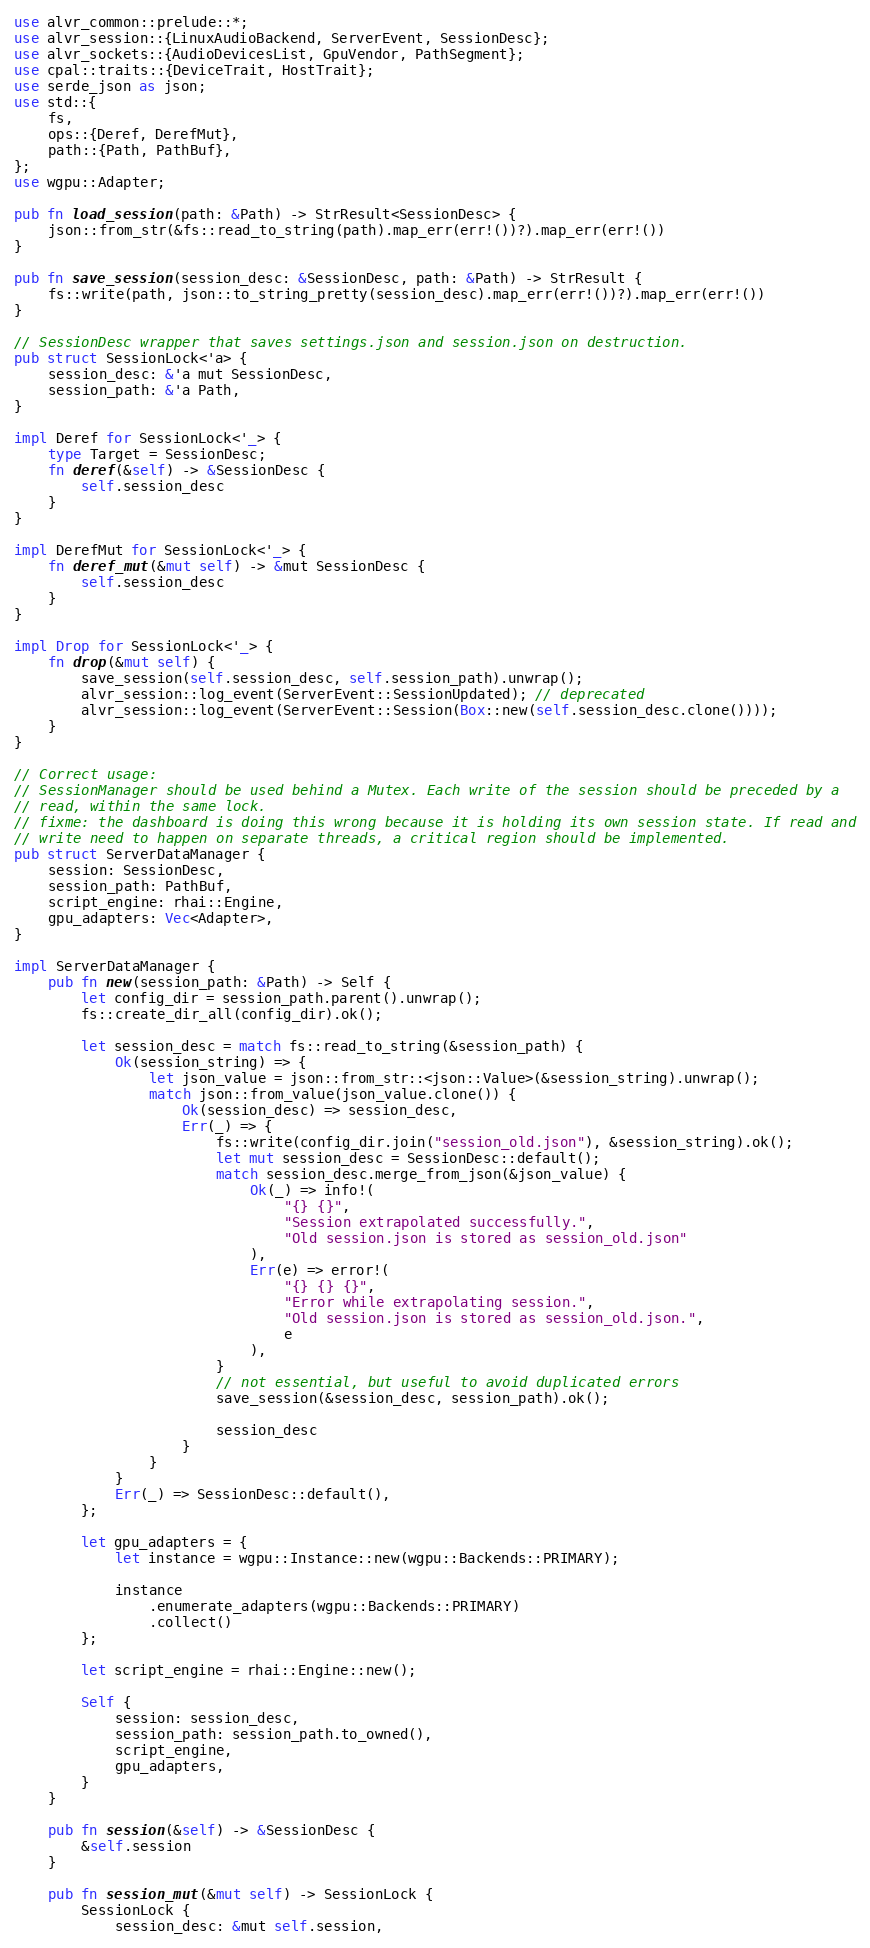Convert code to text. <code><loc_0><loc_0><loc_500><loc_500><_Rust_>use alvr_common::prelude::*;
use alvr_session::{LinuxAudioBackend, ServerEvent, SessionDesc};
use alvr_sockets::{AudioDevicesList, GpuVendor, PathSegment};
use cpal::traits::{DeviceTrait, HostTrait};
use serde_json as json;
use std::{
    fs,
    ops::{Deref, DerefMut},
    path::{Path, PathBuf},
};
use wgpu::Adapter;

pub fn load_session(path: &Path) -> StrResult<SessionDesc> {
    json::from_str(&fs::read_to_string(path).map_err(err!())?).map_err(err!())
}

pub fn save_session(session_desc: &SessionDesc, path: &Path) -> StrResult {
    fs::write(path, json::to_string_pretty(session_desc).map_err(err!())?).map_err(err!())
}

// SessionDesc wrapper that saves settings.json and session.json on destruction.
pub struct SessionLock<'a> {
    session_desc: &'a mut SessionDesc,
    session_path: &'a Path,
}

impl Deref for SessionLock<'_> {
    type Target = SessionDesc;
    fn deref(&self) -> &SessionDesc {
        self.session_desc
    }
}

impl DerefMut for SessionLock<'_> {
    fn deref_mut(&mut self) -> &mut SessionDesc {
        self.session_desc
    }
}

impl Drop for SessionLock<'_> {
    fn drop(&mut self) {
        save_session(self.session_desc, self.session_path).unwrap();
        alvr_session::log_event(ServerEvent::SessionUpdated); // deprecated
        alvr_session::log_event(ServerEvent::Session(Box::new(self.session_desc.clone())));
    }
}

// Correct usage:
// SessionManager should be used behind a Mutex. Each write of the session should be preceded by a
// read, within the same lock.
// fixme: the dashboard is doing this wrong because it is holding its own session state. If read and
// write need to happen on separate threads, a critical region should be implemented.
pub struct ServerDataManager {
    session: SessionDesc,
    session_path: PathBuf,
    script_engine: rhai::Engine,
    gpu_adapters: Vec<Adapter>,
}

impl ServerDataManager {
    pub fn new(session_path: &Path) -> Self {
        let config_dir = session_path.parent().unwrap();
        fs::create_dir_all(config_dir).ok();

        let session_desc = match fs::read_to_string(&session_path) {
            Ok(session_string) => {
                let json_value = json::from_str::<json::Value>(&session_string).unwrap();
                match json::from_value(json_value.clone()) {
                    Ok(session_desc) => session_desc,
                    Err(_) => {
                        fs::write(config_dir.join("session_old.json"), &session_string).ok();
                        let mut session_desc = SessionDesc::default();
                        match session_desc.merge_from_json(&json_value) {
                            Ok(_) => info!(
                                "{} {}",
                                "Session extrapolated successfully.",
                                "Old session.json is stored as session_old.json"
                            ),
                            Err(e) => error!(
                                "{} {} {}",
                                "Error while extrapolating session.",
                                "Old session.json is stored as session_old.json.",
                                e
                            ),
                        }
                        // not essential, but useful to avoid duplicated errors
                        save_session(&session_desc, session_path).ok();

                        session_desc
                    }
                }
            }
            Err(_) => SessionDesc::default(),
        };

        let gpu_adapters = {
            let instance = wgpu::Instance::new(wgpu::Backends::PRIMARY);

            instance
                .enumerate_adapters(wgpu::Backends::PRIMARY)
                .collect()
        };

        let script_engine = rhai::Engine::new();

        Self {
            session: session_desc,
            session_path: session_path.to_owned(),
            script_engine,
            gpu_adapters,
        }
    }

    pub fn session(&self) -> &SessionDesc {
        &self.session
    }

    pub fn session_mut(&mut self) -> SessionLock {
        SessionLock {
            session_desc: &mut self.session,</code> 